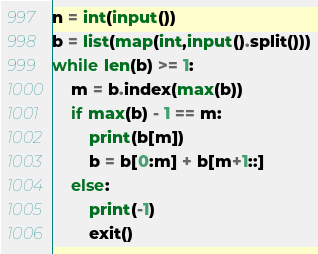Convert code to text. <code><loc_0><loc_0><loc_500><loc_500><_Python_>n = int(input())
b = list(map(int,input().split()))
while len(b) >= 1:
    m = b.index(max(b))
    if max(b) - 1 == m:
        print(b[m])
        b = b[0:m] + b[m+1::]
    else:
        print(-1)
        exit()</code> 